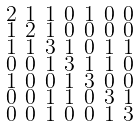<formula> <loc_0><loc_0><loc_500><loc_500>\begin{smallmatrix} 2 & 1 & 1 & 0 & 1 & 0 & 0 \\ 1 & 2 & 1 & 0 & 0 & 0 & 0 \\ 1 & 1 & 3 & 1 & 0 & 1 & 1 \\ 0 & 0 & 1 & 3 & 1 & 1 & 0 \\ 1 & 0 & 0 & 1 & 3 & 0 & 0 \\ 0 & 0 & 1 & 1 & 0 & 3 & 1 \\ 0 & 0 & 1 & 0 & 0 & 1 & 3 \end{smallmatrix}</formula> 